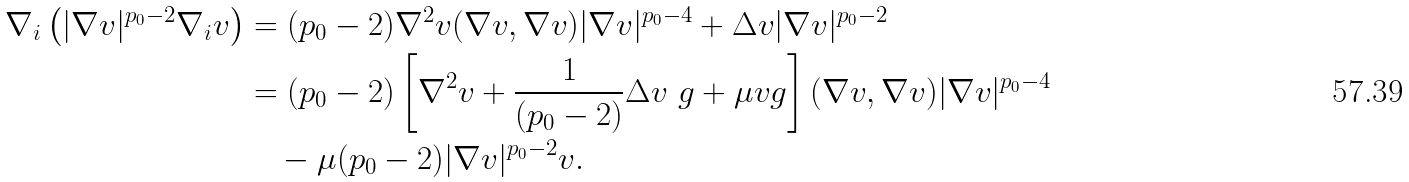<formula> <loc_0><loc_0><loc_500><loc_500>\nabla _ { i } \left ( | \nabla v | ^ { p _ { 0 } - 2 } \nabla _ { i } v \right ) & = ( p _ { 0 } - 2 ) \nabla ^ { 2 } v ( \nabla v , \nabla v ) | \nabla v | ^ { p _ { 0 } - 4 } + \Delta v | \nabla v | ^ { p _ { 0 } - 2 } \\ & = ( p _ { 0 } - 2 ) \left [ \nabla ^ { 2 } v + \frac { 1 } { ( p _ { 0 } - 2 ) } \Delta v \ g + \mu v g \right ] ( \nabla v , \nabla v ) | \nabla v | ^ { p _ { 0 } - 4 } \\ & \quad - \mu ( p _ { 0 } - 2 ) | \nabla v | ^ { p _ { 0 } - 2 } v .</formula> 